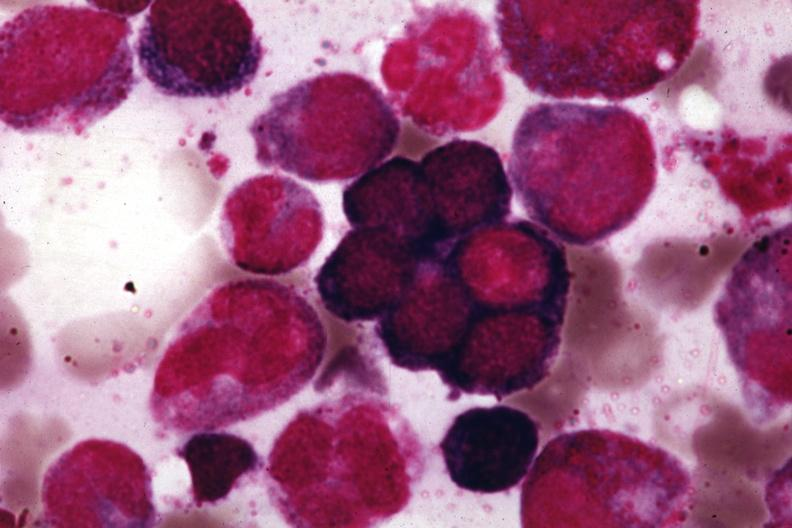what is present?
Answer the question using a single word or phrase. Bone marrow 